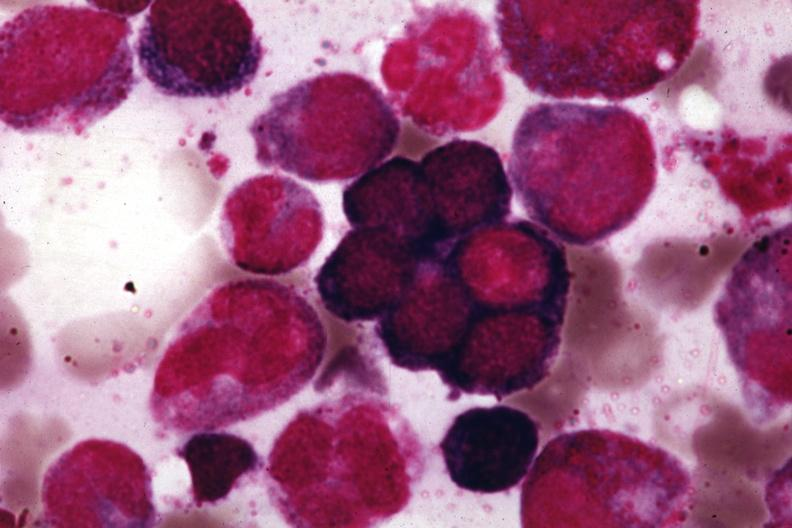what is present?
Answer the question using a single word or phrase. Bone marrow 